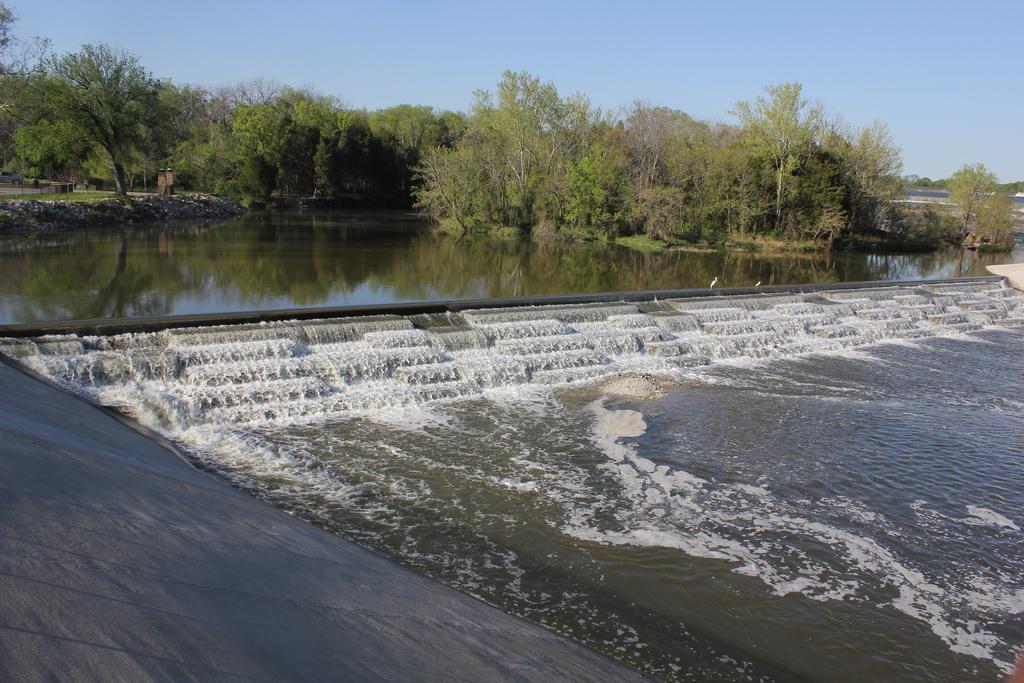Please provide a concise description of this image. In this picture there is water in the center of the image and there are trees at the top side of the image. 